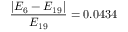<formula> <loc_0><loc_0><loc_500><loc_500>\frac { | E _ { 6 } - E _ { 1 9 } | } { E _ { 1 9 } } = 0 . 0 4 3 4</formula> 